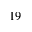<formula> <loc_0><loc_0><loc_500><loc_500>1 9</formula> 